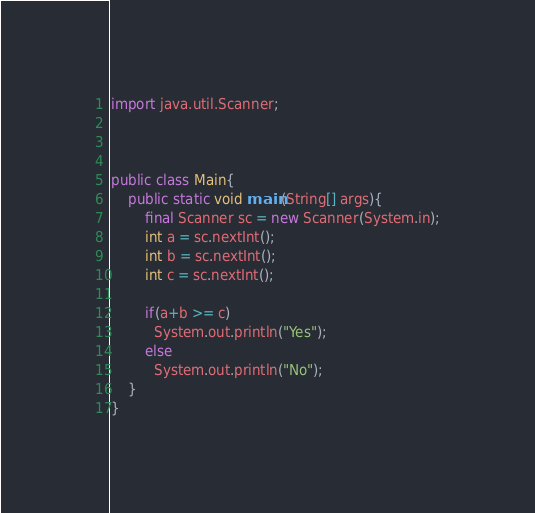<code> <loc_0><loc_0><loc_500><loc_500><_Java_>import java.util.Scanner;



public class Main{
    public static void main(String[] args){
        final Scanner sc = new Scanner(System.in);
        int a = sc.nextInt();
        int b = sc.nextInt();
        int c = sc.nextInt();

        if(a+b >= c)
          System.out.println("Yes");
        else
          System.out.println("No");
    }
}
</code> 